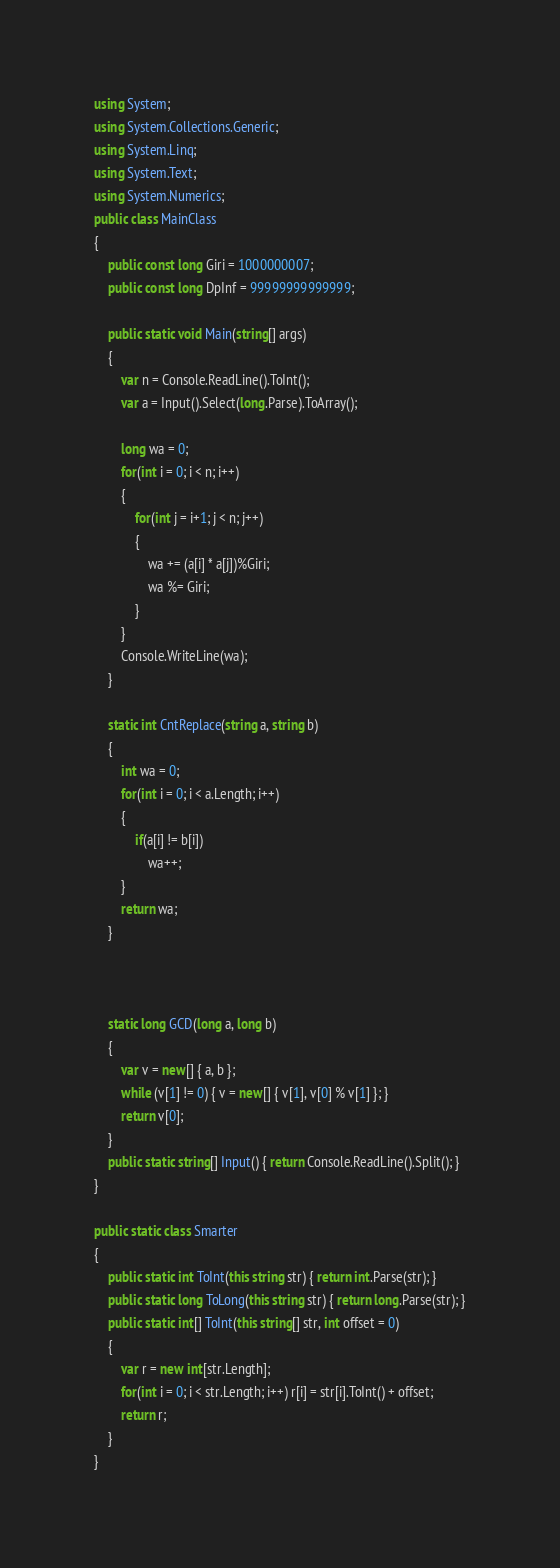Convert code to text. <code><loc_0><loc_0><loc_500><loc_500><_C#_>using System;
using System.Collections.Generic;
using System.Linq;
using System.Text;
using System.Numerics;
public class MainClass
{
	public const long Giri = 1000000007;
	public const long DpInf = 99999999999999;
	
	public static void Main(string[] args)
	{
		var n = Console.ReadLine().ToInt();
		var a = Input().Select(long.Parse).ToArray();
		
		long wa = 0;
		for(int i = 0; i < n; i++)
		{
			for(int j = i+1; j < n; j++)
			{
				wa += (a[i] * a[j])%Giri;
				wa %= Giri;
			}
		}
		Console.WriteLine(wa);
	}
	
	static int CntReplace(string a, string b)
	{
		int wa = 0;
		for(int i = 0; i < a.Length; i++)
		{
			if(a[i] != b[i])
				wa++;
		}
		return wa;
	}

	
	
	static long GCD(long a, long b)
	{
		var v = new[] { a, b };
		while (v[1] != 0) { v = new[] { v[1], v[0] % v[1] }; }
		return v[0];
	}
	public static string[] Input() { return Console.ReadLine().Split(); }
}

public static class Smarter
{
	public static int ToInt(this string str) { return int.Parse(str); }
	public static long ToLong(this string str) { return long.Parse(str); }
	public static int[] ToInt(this string[] str, int offset = 0)
	{
		var r = new int[str.Length];
		for(int i = 0; i < str.Length; i++) r[i] = str[i].ToInt() + offset;
		return r;
	}
}
</code> 